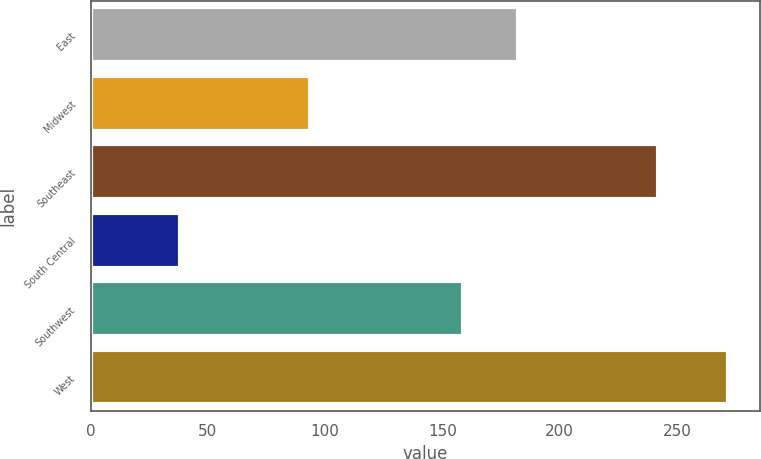<chart> <loc_0><loc_0><loc_500><loc_500><bar_chart><fcel>East<fcel>Midwest<fcel>Southeast<fcel>South Central<fcel>Southwest<fcel>West<nl><fcel>182.08<fcel>93.6<fcel>241.7<fcel>38.1<fcel>158.7<fcel>271.9<nl></chart> 